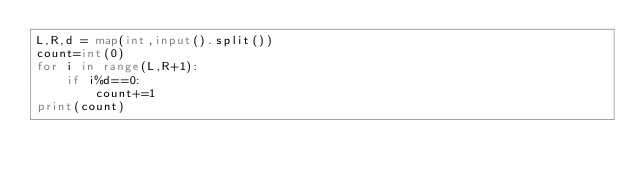<code> <loc_0><loc_0><loc_500><loc_500><_Python_>L,R,d = map(int,input().split())
count=int(0)
for i in range(L,R+1):
    if i%d==0:
        count+=1
print(count)
</code> 